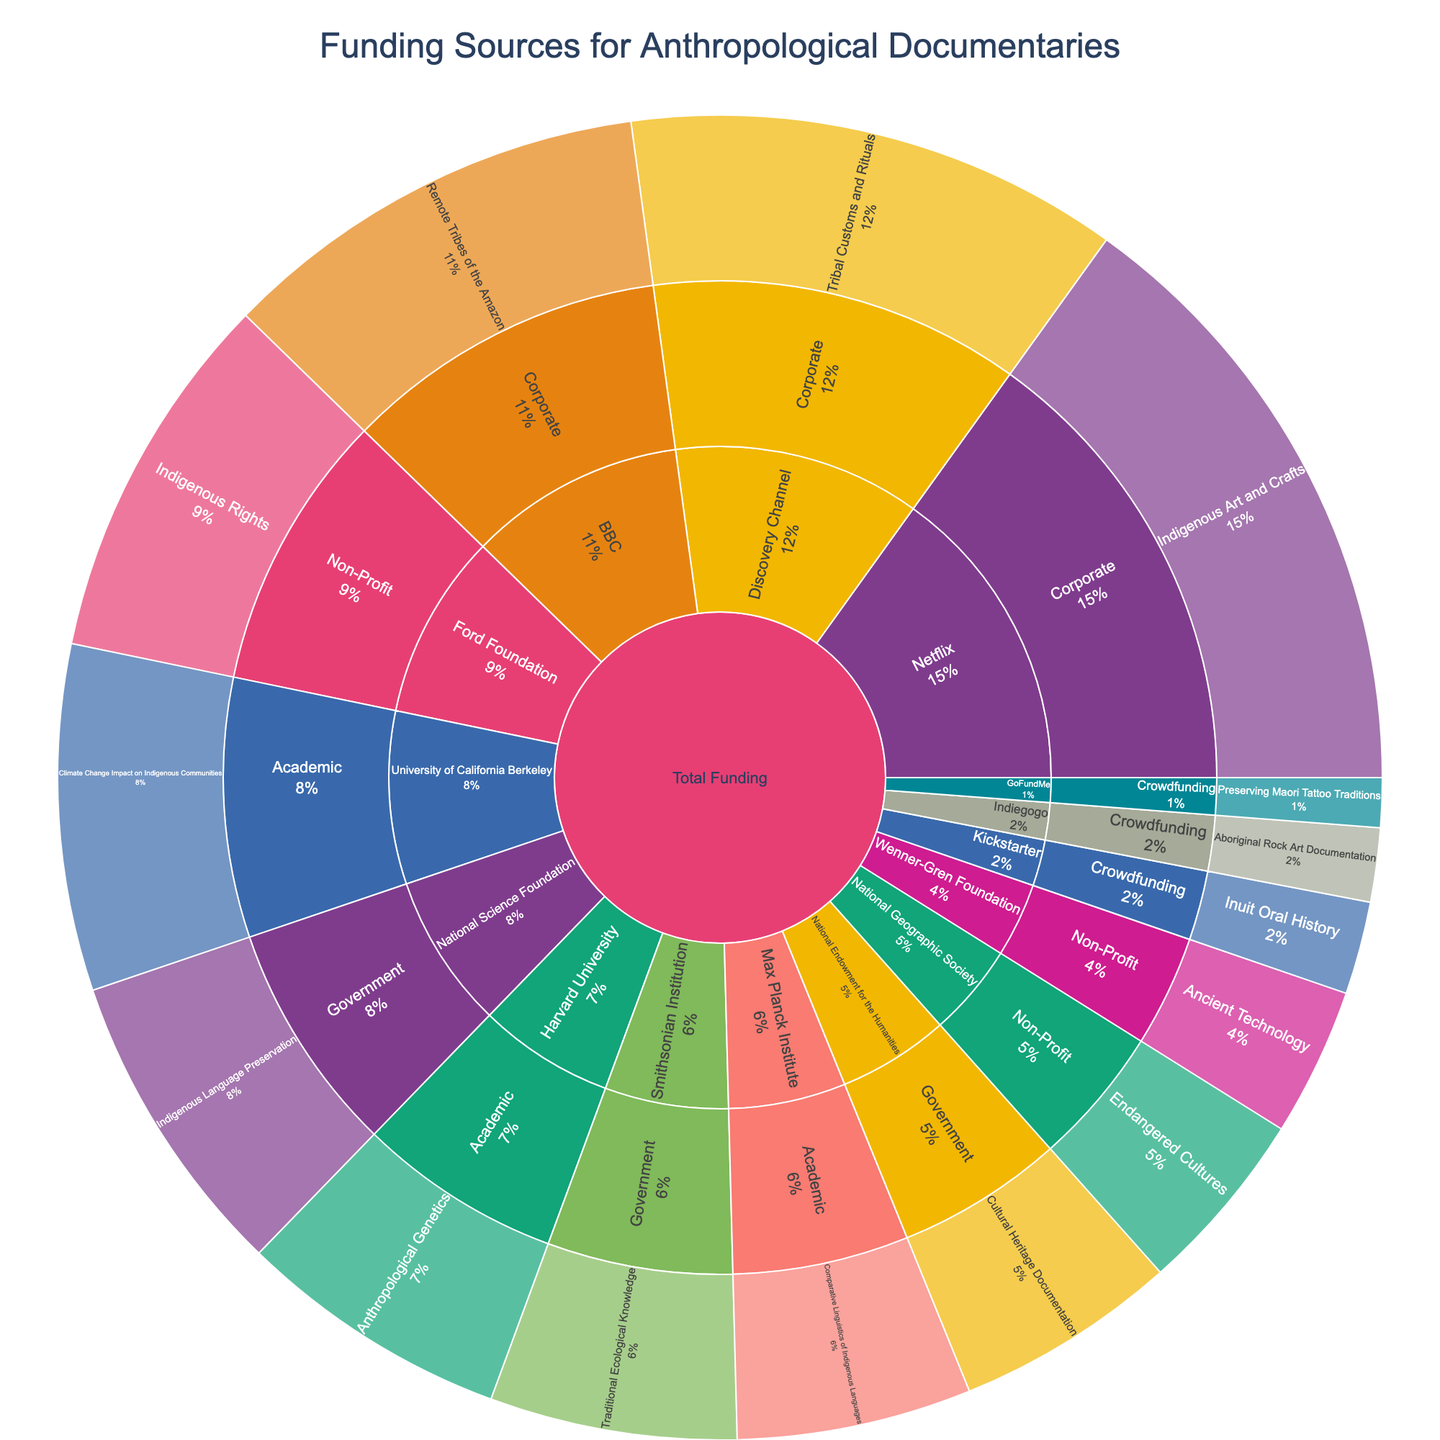What's the title of the figure? The title is usually displayed at the top of a figure. In this case, the title states, "Funding Sources for Anthropological Documentaries."
Answer: Funding Sources for Anthropological Documentaries How many types of funding sources are there? Examine the second level of the sunburst plot, which shows the different types of funding sources. There are four distinct types: Government, Non-Profit, Corporate, and Academic.
Answer: Four types What type of funder provides the largest amount of funding for a single project? To determine the largest amount of funding for a single project, look at each type of funder and identify the highest individual funding amount. Netflix in the Corporate category provides $500,000 for Indigenous Art and Crafts.
Answer: Corporate (Netflix) Which project focus receives the most funding overall from the Non-Profit category? To find the project focus with the most funding in the Non-Profit category, add up the funding amounts for each project focus within Non-Profit. The project "Indigenous Rights" from Ford Foundation in Non-Profit results in $300,000, which is the highest.
Answer: Indigenous Rights How much more funding does Corporate provide compared to Crowdfunding? Sum the total funding for each type: Corporate (400,000 + 350,000 + 500,000) = $1,250,000 and Crowdfunding (75,000 + 60,000 + 40,000) = $175,000. Then, compute the difference: $1,250,000 - $175,000 = $1,075,000.
Answer: $1,075,000 What percentage of the total funding does the Government category contribute? To find the percentage contributed by the Government category, first identify the total funding across all types. Total funding is the sum of all amounts provided in the plot. Sum the funding for Government (250,000 + 180,000 + 200,000) = $630,000. Calculate the percentage: ($630,000 / Total Funding) * 100%. Assuming total funding is $2,835,000 (sum of all provided amounts), it's ($630,000 / $2,835,000) * 100% ≈ 22.2%.
Answer: 22.2% Which project focus receives the least amount of total funding? Examine the plot to identify the project focus with the smallest individual funding amount. The "Preserving Maori Tattoo Traditions" project in Crowdfunding receives $40,000, which is the least.
Answer: Preserving Maori Tattoo Traditions How does funding from Academic sources compare to the Government sources in terms of project diversity? Identify the number of distinct project focuses funded by Academic and Government sources. Academic funds three projects: Anthropological Genetics, Climate Change Impact on Indigenous Communities, and Comparative Linguistics of Indigenous Languages. Government also funds three projects: Indigenous Language Preservation, Cultural Heritage Documentation, and Traditional Ecological Knowledge. Both types fund an equal number of different projects.
Answer: Equal diversity Which type of funder provides the highest average funding amount per project? Calculate the average funding amount for each type by dividing the total funding by the number of projects they fund. Government funds three projects with $630,000, so average: $630,000 / 3 = $210,000. Non-Profit: $570,000 for three projects, so average: $570,000 / 3 = $190,000. Corporate: $1,250,000 for three projects, so average: $1,250,000 / 3 ≈ $416,667. Academic: $690,000 for three projects, so average: $690,000 / 3 = $230,000. Crowdfunding: $175,000 for three projects, so average: $175,000 / 3 ≈ $58,333. Corporate provides the highest average funding amount per project.
Answer: Corporate 